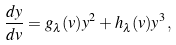<formula> <loc_0><loc_0><loc_500><loc_500>\frac { d y } { d v } = g _ { \lambda } ( v ) y ^ { 2 } + h _ { \lambda } ( v ) y ^ { 3 } ,</formula> 